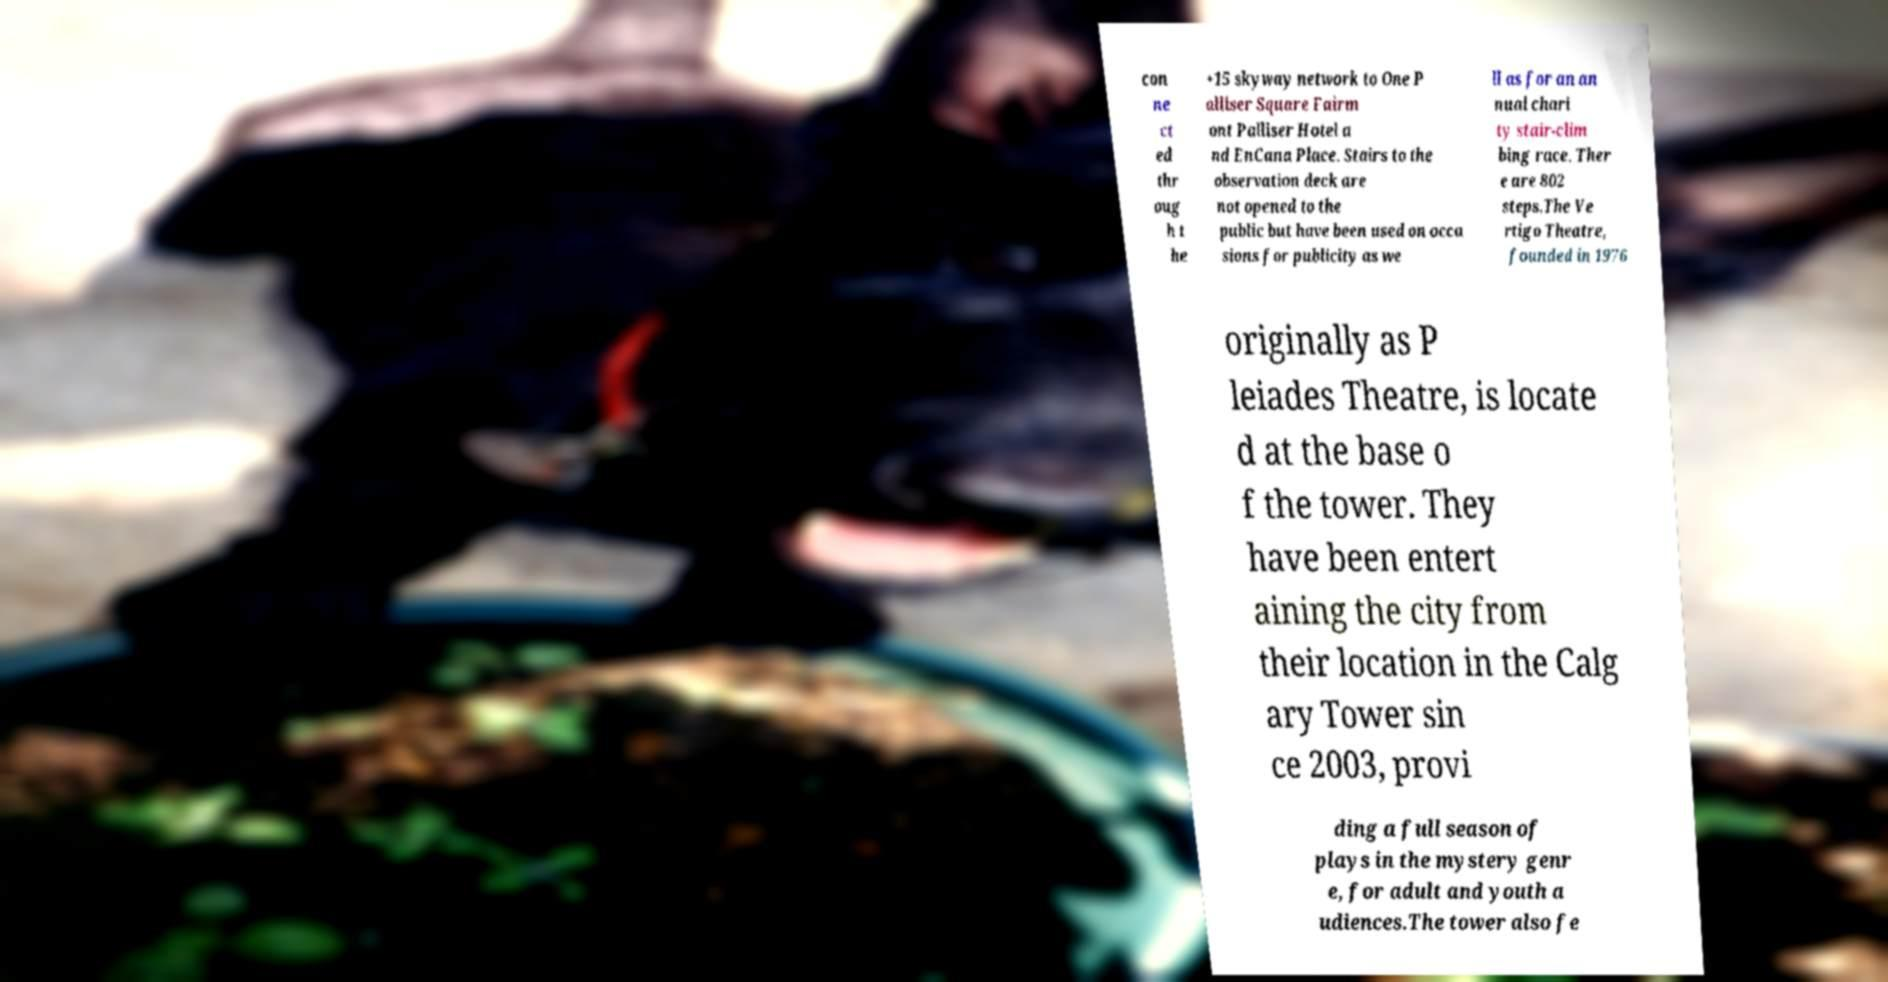Could you extract and type out the text from this image? con ne ct ed thr oug h t he +15 skyway network to One P alliser Square Fairm ont Palliser Hotel a nd EnCana Place. Stairs to the observation deck are not opened to the public but have been used on occa sions for publicity as we ll as for an an nual chari ty stair-clim bing race. Ther e are 802 steps.The Ve rtigo Theatre, founded in 1976 originally as P leiades Theatre, is locate d at the base o f the tower. They have been entert aining the city from their location in the Calg ary Tower sin ce 2003, provi ding a full season of plays in the mystery genr e, for adult and youth a udiences.The tower also fe 